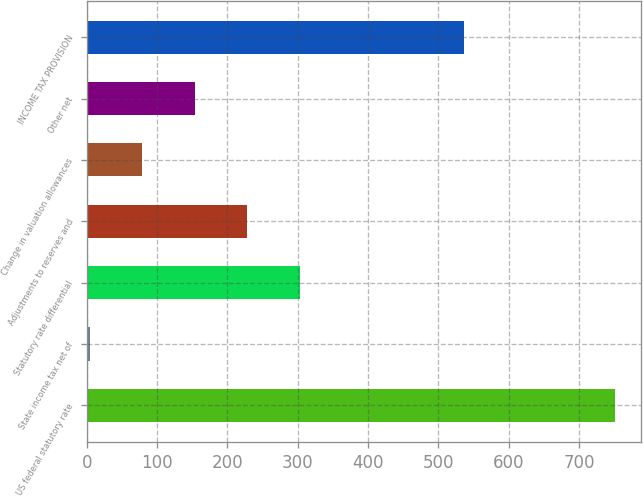Convert chart. <chart><loc_0><loc_0><loc_500><loc_500><bar_chart><fcel>US federal statutory rate<fcel>State income tax net of<fcel>Statutory rate differential<fcel>Adjustments to reserves and<fcel>Change in valuation allowances<fcel>Other net<fcel>INCOME TAX PROVISION<nl><fcel>751<fcel>4<fcel>302.8<fcel>228.1<fcel>78.7<fcel>153.4<fcel>537<nl></chart> 